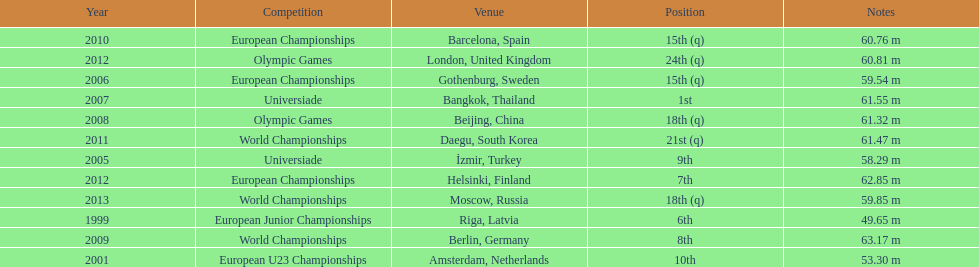Can you parse all the data within this table? {'header': ['Year', 'Competition', 'Venue', 'Position', 'Notes'], 'rows': [['2010', 'European Championships', 'Barcelona, Spain', '15th (q)', '60.76 m'], ['2012', 'Olympic Games', 'London, United Kingdom', '24th (q)', '60.81 m'], ['2006', 'European Championships', 'Gothenburg, Sweden', '15th (q)', '59.54 m'], ['2007', 'Universiade', 'Bangkok, Thailand', '1st', '61.55 m'], ['2008', 'Olympic Games', 'Beijing, China', '18th (q)', '61.32 m'], ['2011', 'World Championships', 'Daegu, South Korea', '21st (q)', '61.47 m'], ['2005', 'Universiade', 'İzmir, Turkey', '9th', '58.29 m'], ['2012', 'European Championships', 'Helsinki, Finland', '7th', '62.85 m'], ['2013', 'World Championships', 'Moscow, Russia', '18th (q)', '59.85 m'], ['1999', 'European Junior Championships', 'Riga, Latvia', '6th', '49.65 m'], ['2009', 'World Championships', 'Berlin, Germany', '8th', '63.17 m'], ['2001', 'European U23 Championships', 'Amsterdam, Netherlands', '10th', '53.30 m']]} What was mayer's best result: i.e his longest throw? 63.17 m. 